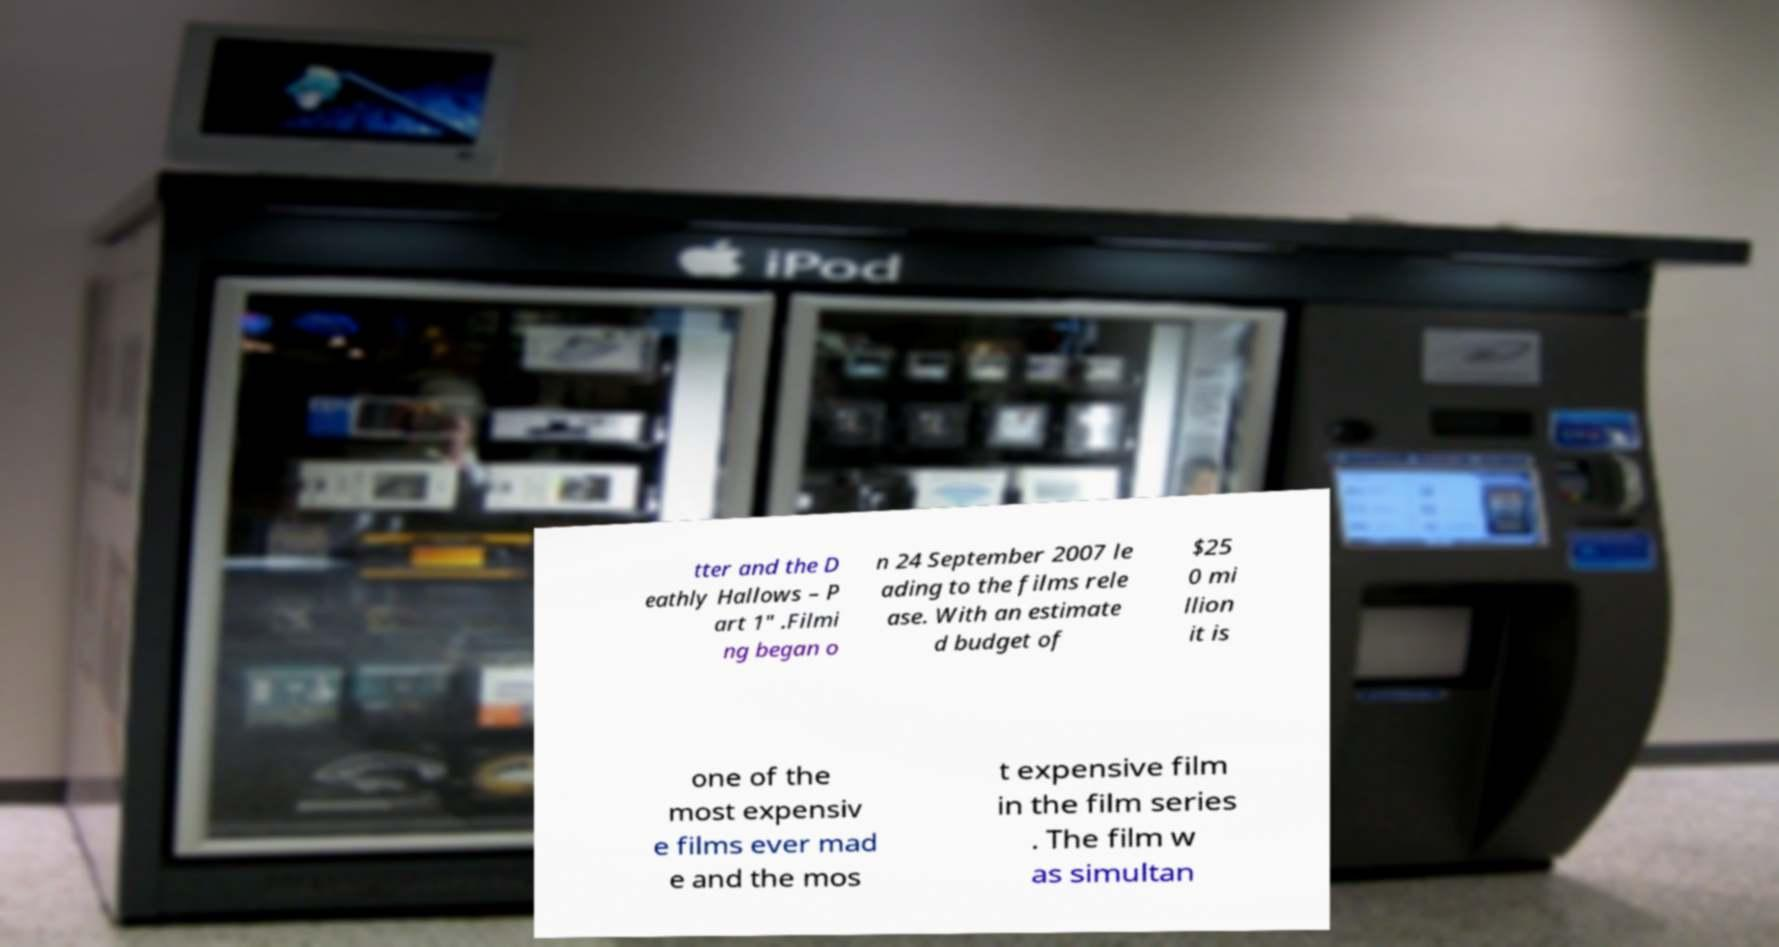Can you accurately transcribe the text from the provided image for me? tter and the D eathly Hallows – P art 1" .Filmi ng began o n 24 September 2007 le ading to the films rele ase. With an estimate d budget of $25 0 mi llion it is one of the most expensiv e films ever mad e and the mos t expensive film in the film series . The film w as simultan 